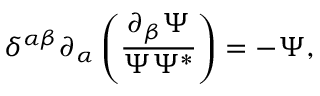<formula> <loc_0><loc_0><loc_500><loc_500>\delta ^ { \alpha \beta } \partial _ { \alpha } \left ( \frac { \partial _ { \beta } \Psi } { \Psi \Psi ^ { * } } \right ) = - \Psi ,</formula> 